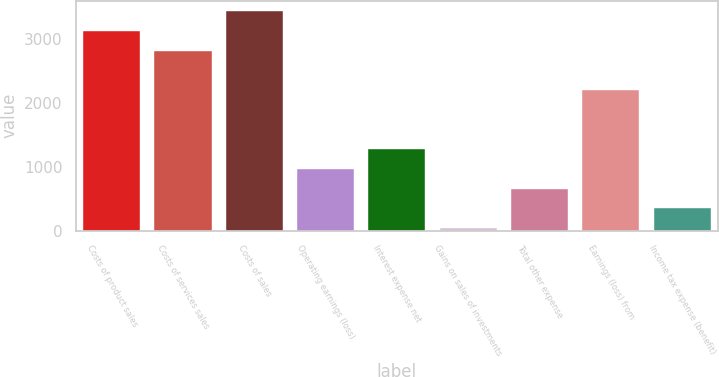Convert chart. <chart><loc_0><loc_0><loc_500><loc_500><bar_chart><fcel>Costs of product sales<fcel>Costs of services sales<fcel>Costs of sales<fcel>Operating earnings (loss)<fcel>Interest expense net<fcel>Gains on sales of investments<fcel>Total other expense<fcel>Earnings (loss) from<fcel>Income tax expense (benefit)<nl><fcel>3118<fcel>2809.9<fcel>3426.1<fcel>961.3<fcel>1269.4<fcel>37<fcel>653.2<fcel>2193.7<fcel>345.1<nl></chart> 